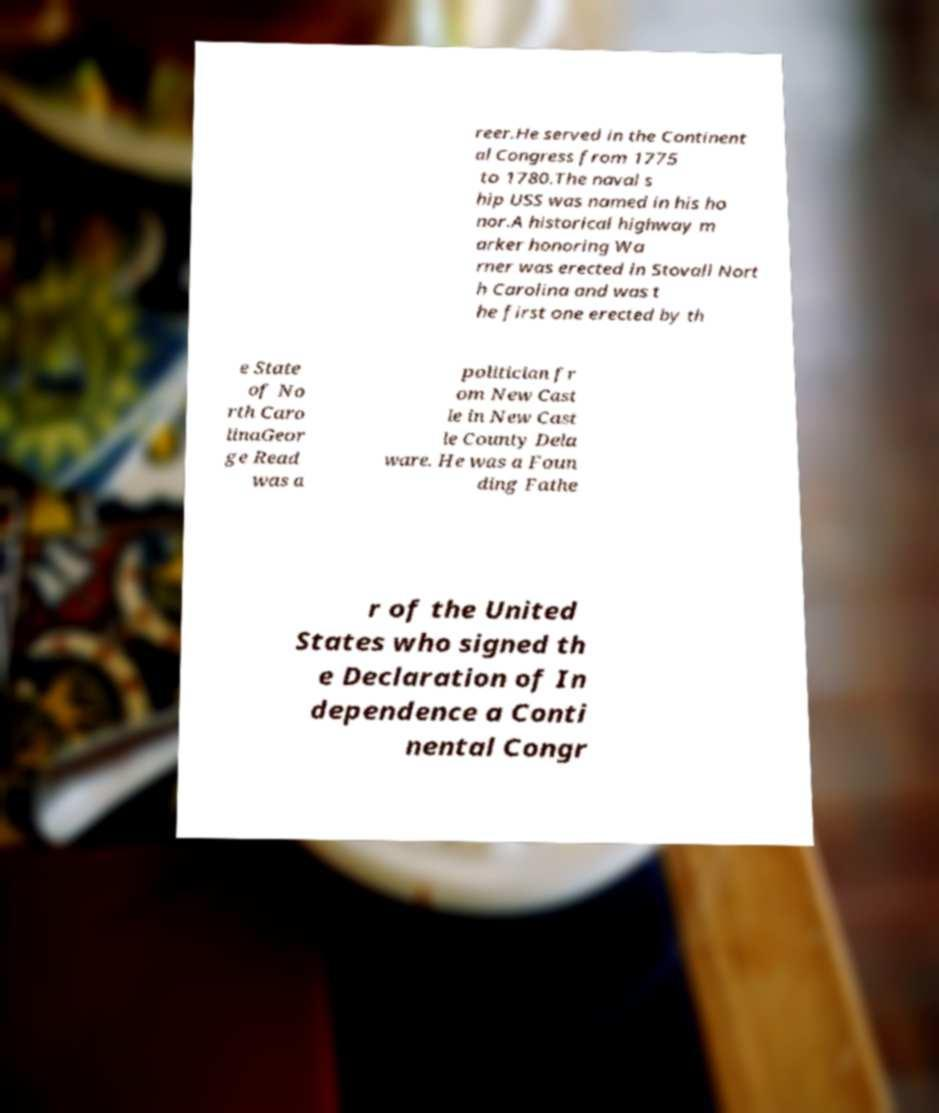Can you accurately transcribe the text from the provided image for me? reer.He served in the Continent al Congress from 1775 to 1780.The naval s hip USS was named in his ho nor.A historical highway m arker honoring Wa rner was erected in Stovall Nort h Carolina and was t he first one erected by th e State of No rth Caro linaGeor ge Read was a politician fr om New Cast le in New Cast le County Dela ware. He was a Foun ding Fathe r of the United States who signed th e Declaration of In dependence a Conti nental Congr 